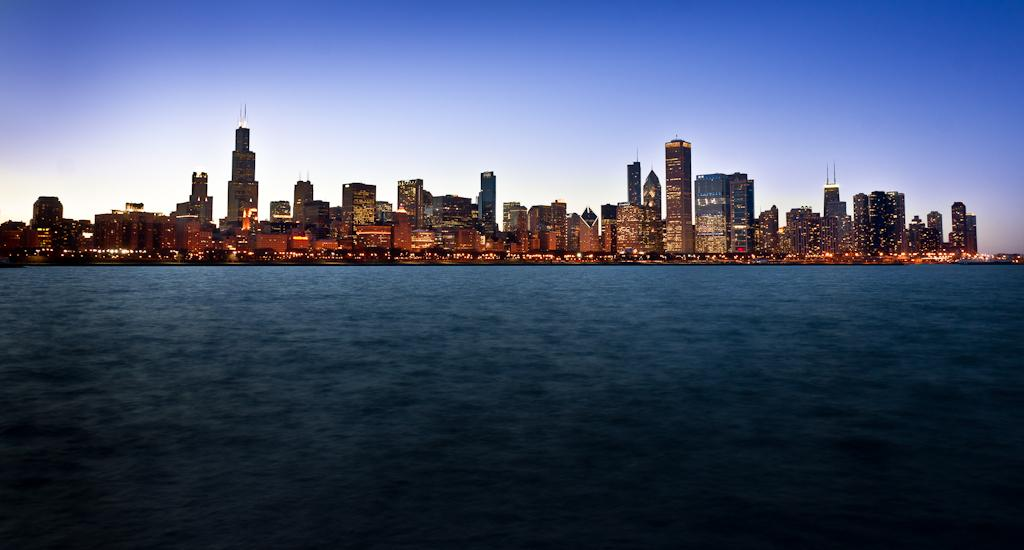What is visible in the image? Water is visible in the image. What can be seen in the background of the image? There are buildings and the sky visible in the background of the image. How many trucks are parked near the water in the image? There are no trucks visible in the image; it only features water, buildings, and the sky. 